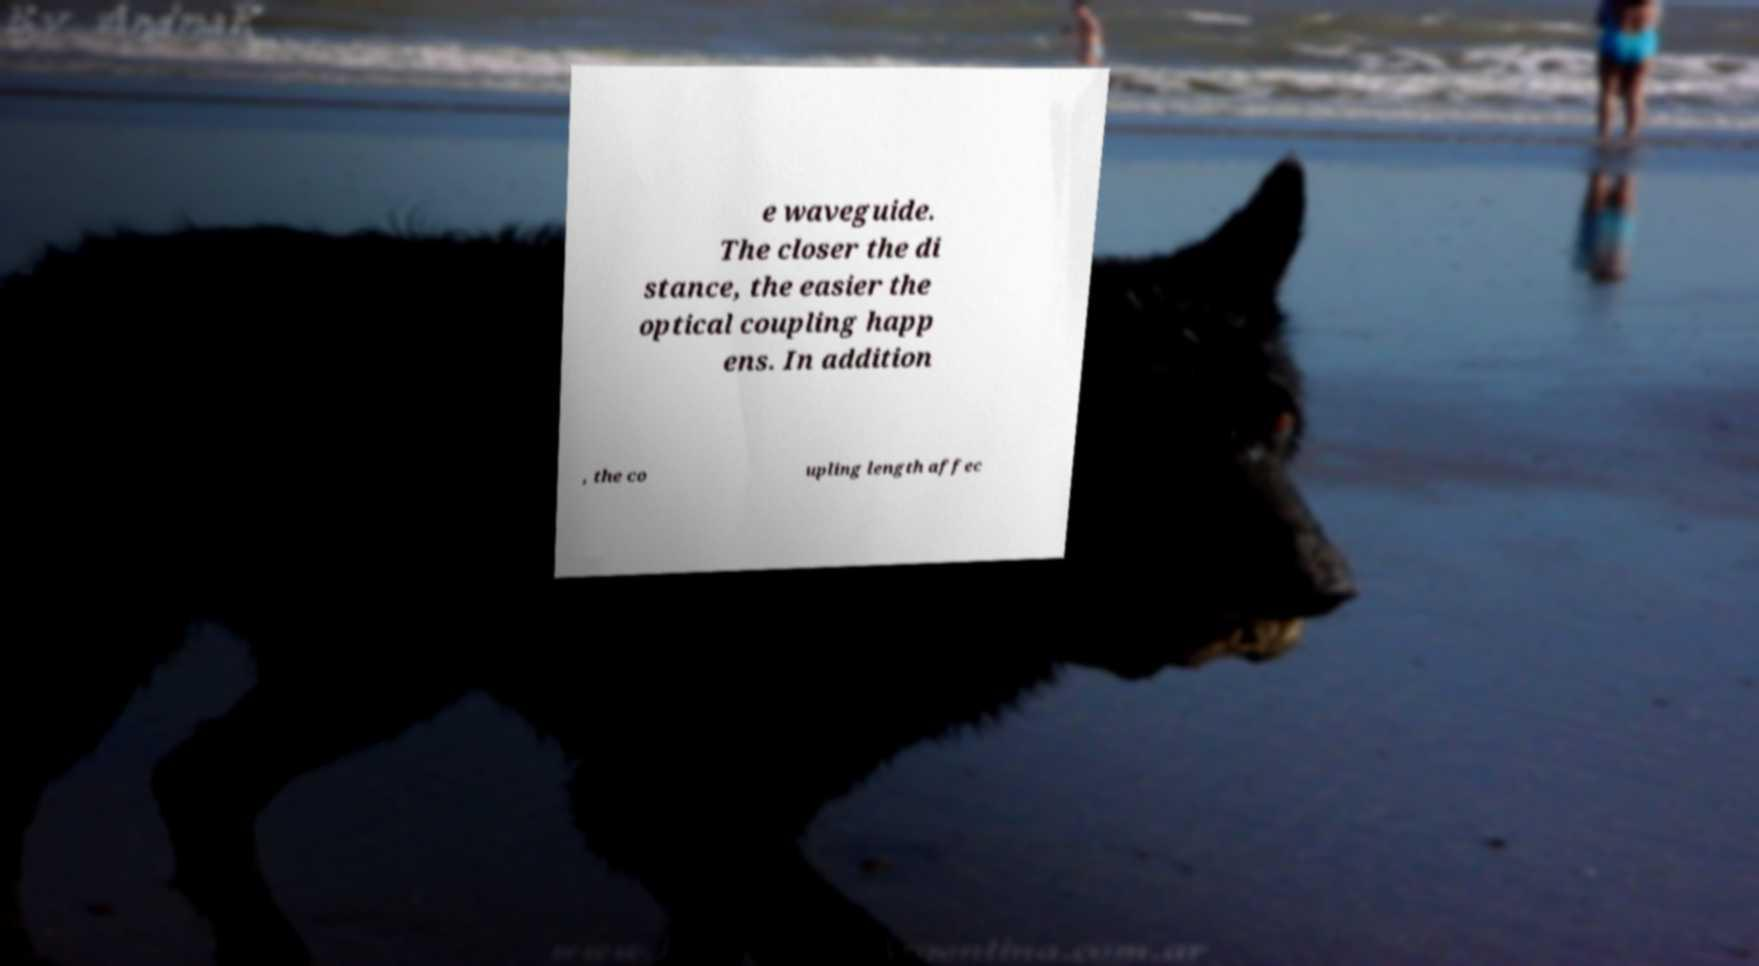For documentation purposes, I need the text within this image transcribed. Could you provide that? e waveguide. The closer the di stance, the easier the optical coupling happ ens. In addition , the co upling length affec 